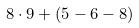<formula> <loc_0><loc_0><loc_500><loc_500>8 \cdot 9 + ( 5 - 6 - 8 )</formula> 